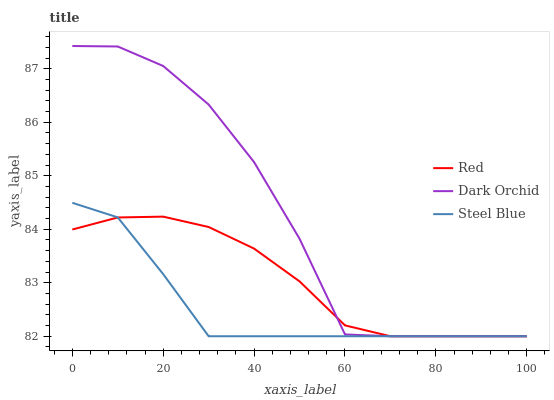Does Steel Blue have the minimum area under the curve?
Answer yes or no. Yes. Does Dark Orchid have the maximum area under the curve?
Answer yes or no. Yes. Does Red have the minimum area under the curve?
Answer yes or no. No. Does Red have the maximum area under the curve?
Answer yes or no. No. Is Red the smoothest?
Answer yes or no. Yes. Is Dark Orchid the roughest?
Answer yes or no. Yes. Is Steel Blue the smoothest?
Answer yes or no. No. Is Steel Blue the roughest?
Answer yes or no. No. Does Dark Orchid have the lowest value?
Answer yes or no. Yes. Does Dark Orchid have the highest value?
Answer yes or no. Yes. Does Steel Blue have the highest value?
Answer yes or no. No. Does Red intersect Dark Orchid?
Answer yes or no. Yes. Is Red less than Dark Orchid?
Answer yes or no. No. Is Red greater than Dark Orchid?
Answer yes or no. No. 